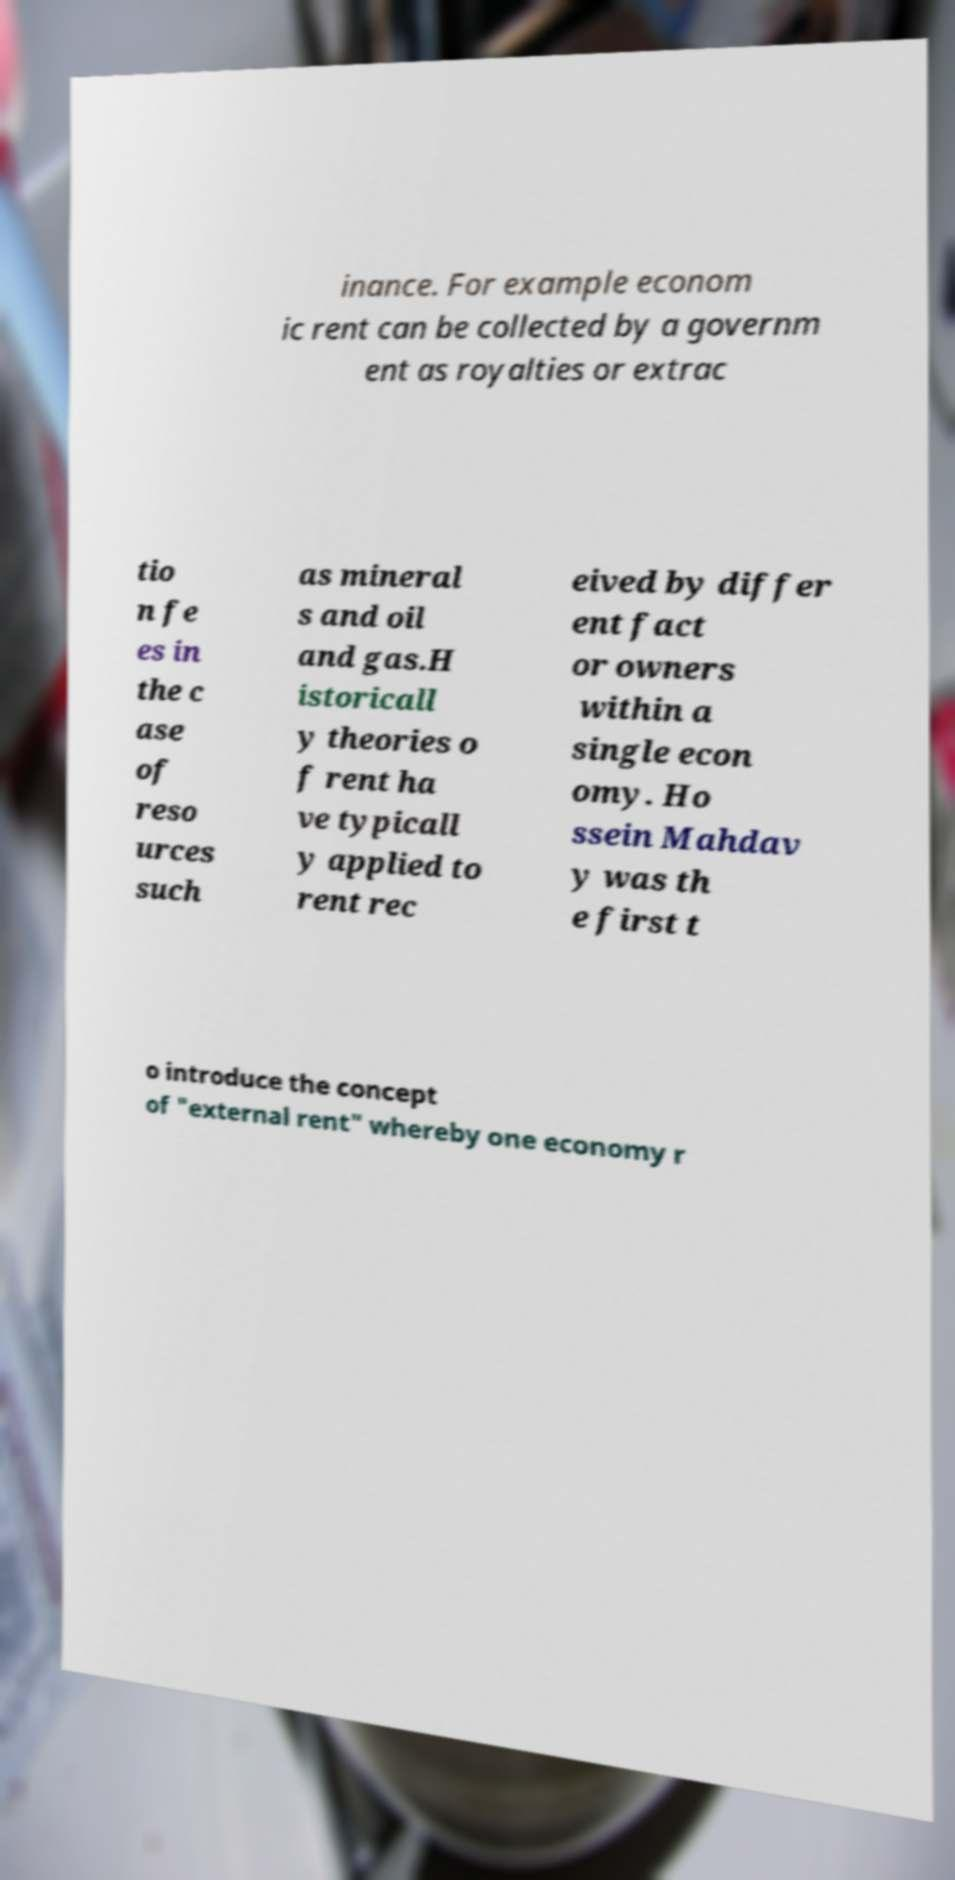Could you extract and type out the text from this image? inance. For example econom ic rent can be collected by a governm ent as royalties or extrac tio n fe es in the c ase of reso urces such as mineral s and oil and gas.H istoricall y theories o f rent ha ve typicall y applied to rent rec eived by differ ent fact or owners within a single econ omy. Ho ssein Mahdav y was th e first t o introduce the concept of "external rent" whereby one economy r 